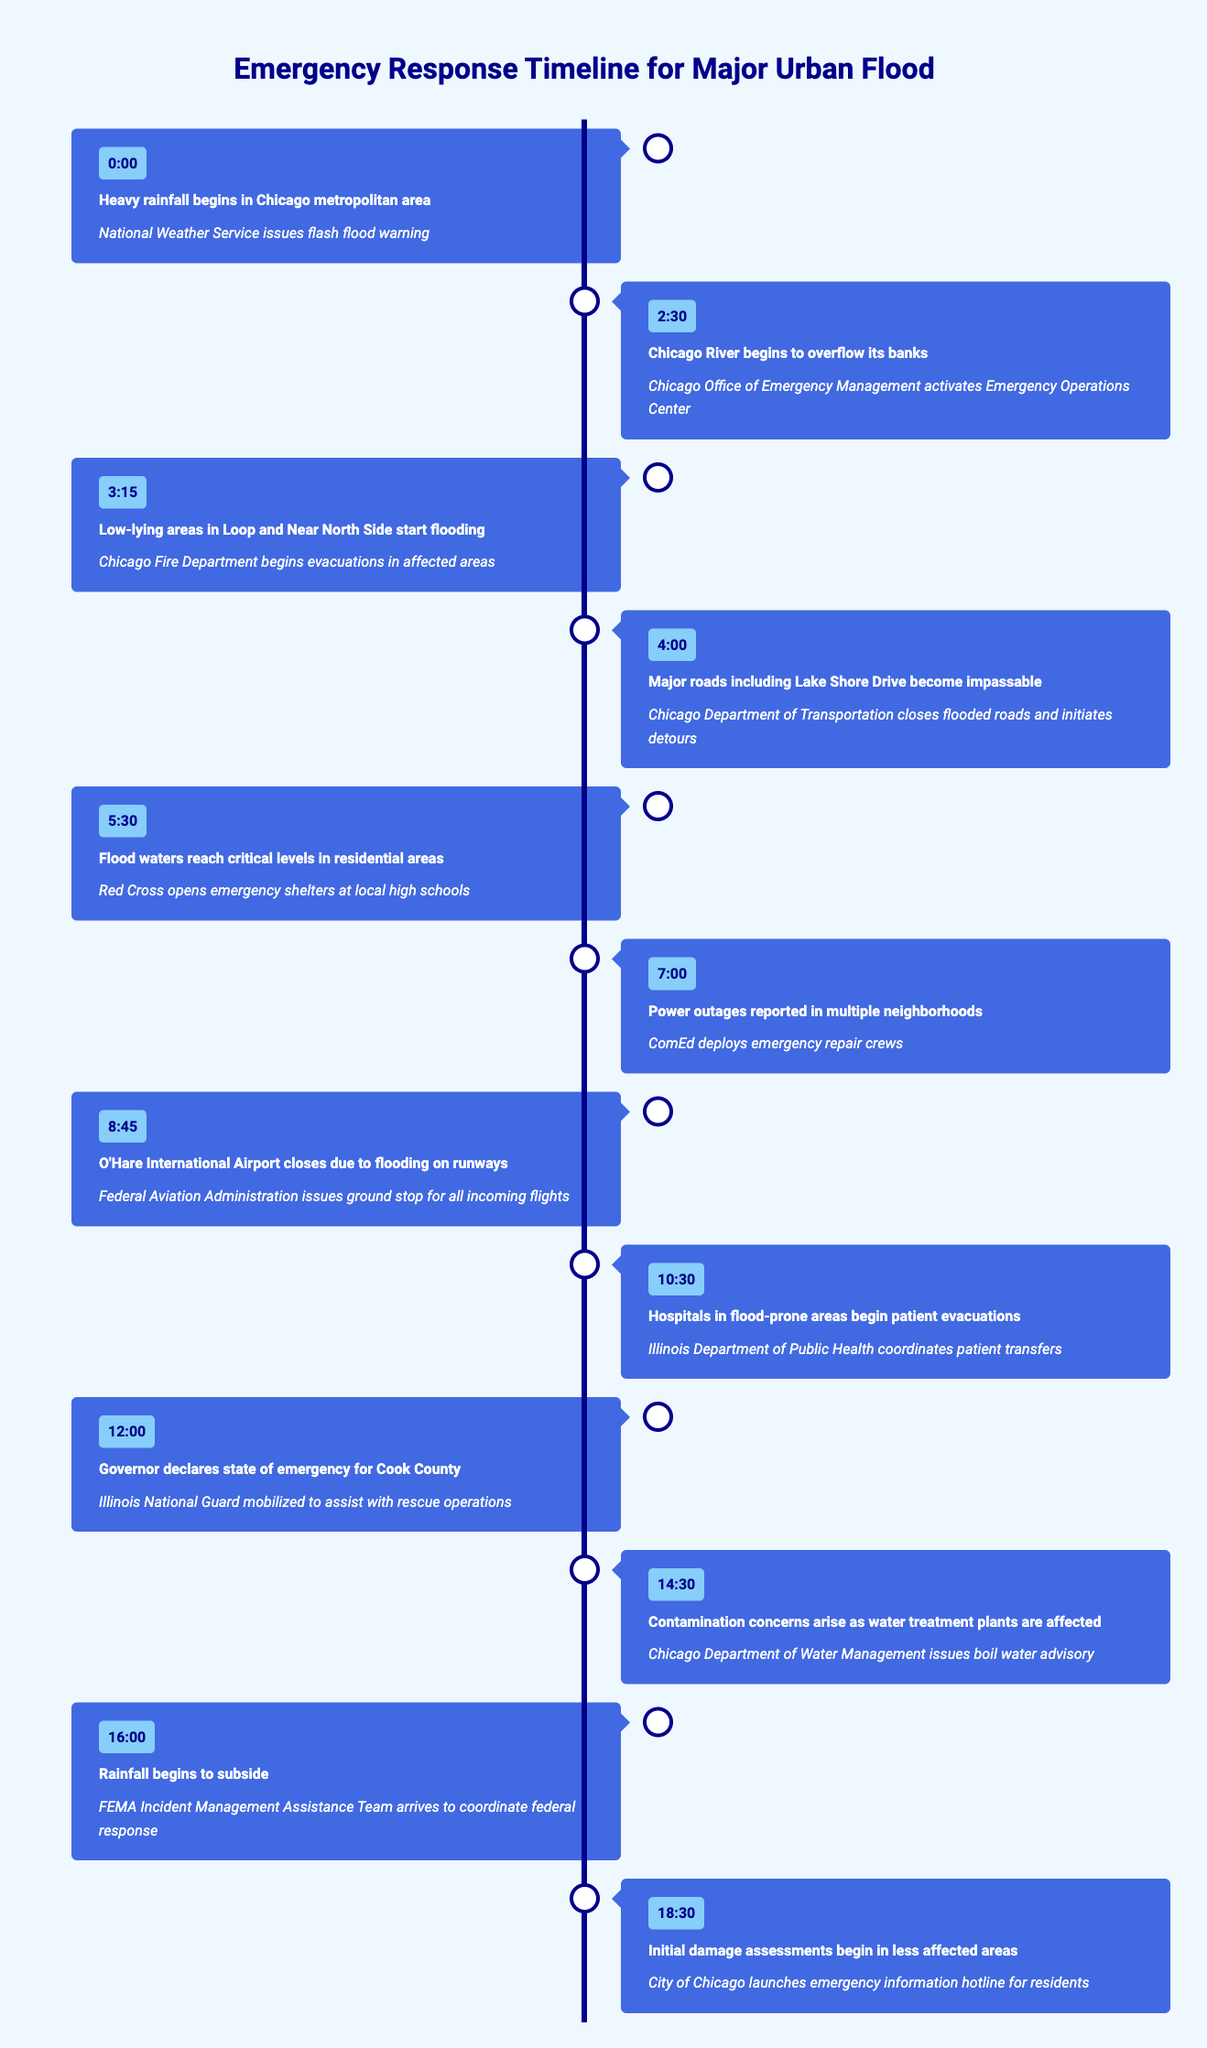What event occurred first in the timeline? The first event in the timeline is "Heavy rainfall begins in Chicago metropolitan area," which is recorded at time 0:00. This is the starting point of the incidents listed in the timeline.
Answer: Heavy rainfall begins in Chicago metropolitan area At what time did the power outages begin? According to the table, power outages were reported at 7:00. This time is clearly marked in the timeline associated with the specific event.
Answer: 7:00 How many hours passed from the start of the rainfall to the declaration of the state of emergency? The rainfall began at 0:00 and the state of emergency was declared at 12:00. To find the duration, calculate the difference: 12:00 - 0:00 = 12 hours.
Answer: 12 hours Did the Red Cross open emergency shelters before evacuation efforts began? The Red Cross opened emergency shelters at 5:30, while evacuation efforts by the Chicago Fire Department began at 3:15. Since 5:30 is after 3:15, the statement is true.
Answer: Yes What actions were taken by the Illinois Department of Public Health? The Illinois Department of Public Health coordinated patient transfers for hospitals in flood-prone areas, as indicated at the time of 10:30.
Answer: Coordinated patient transfers What is the time difference between the flooding in low-lying areas and the closure of O'Hare International Airport? Flooding in low-lying areas began at 3:15 and O'Hare International Airport closed at 8:45. The time difference is calculated as: 8:45 - 3:15 = 5 hours and 30 minutes.
Answer: 5 hours and 30 minutes Which event is associated with the action of issuing a boil water advisory? The boil water advisory was issued by the Chicago Department of Water Management at 14:30 due to contamination concerns arising from affected water treatment plants. This action is clearly tied to the corresponding event listed.
Answer: Contamination concerns arise as water treatment plants are affected Was FEMA's Incident Management Assistance Team present at the onset of the flooding? The FEMA Incident Management Assistance Team arrived to coordinate the federal response at 16:00, which is after the onset of the flooding events that began at 0:00. Therefore, this statement is false.
Answer: No What was the last action listed in the timeline? The last action in the timeline is that the City of Chicago launched an emergency information hotline for residents at 18:30. This is clearly noted as the final event in the table.
Answer: City of Chicago launches emergency information hotline for residents 